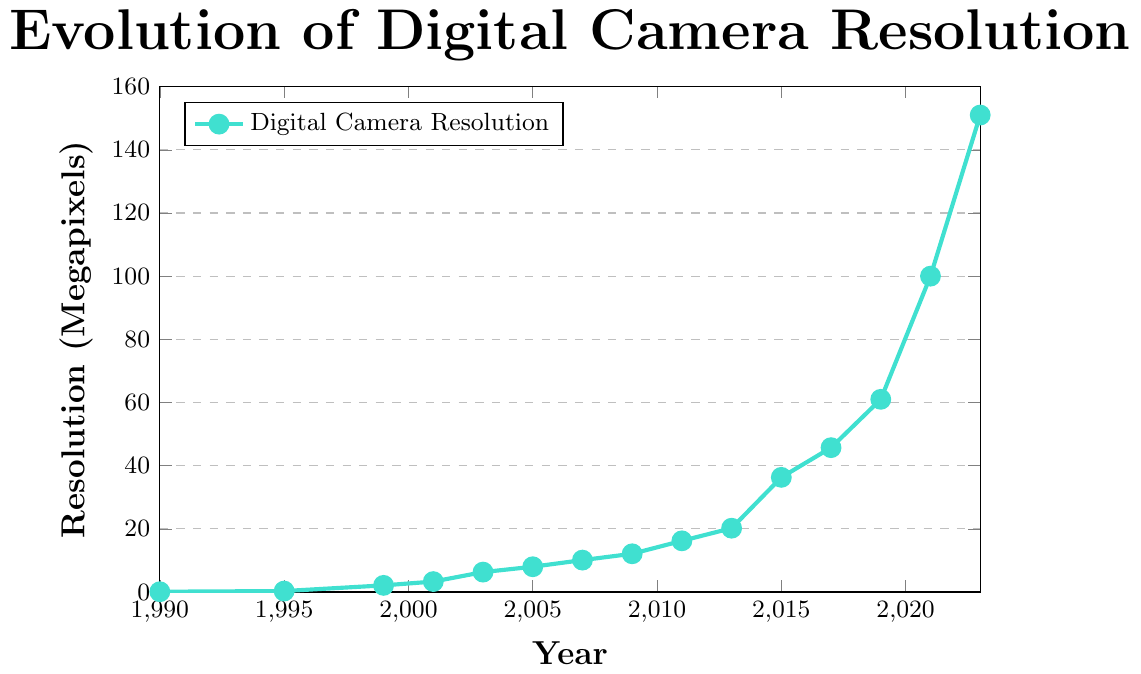What is the resolution trend from 1990 to 2023? The resolution of digital cameras shows a significant upward trend from 1990 to 2023. Starting at 0.09 megapixels in 1990, there is a steady increase with a notable acceleration in resolution improvements after 2011. By 2023, the resolution reaches 151 megapixels.
Answer: Upward Trend Which year shows the most significant jump in resolution? By comparing the differences between consecutive years, the year 2021 shows the most significant increase in resolution. The jump from 61 megapixels in 2019 to 100 megapixels in 2021 is the largest increment.
Answer: 2021 How many years did it take for the resolution to increase from 2.1 megapixels to 16.2 megapixels? The resolution was 2.1 megapixels in 1999 and reached 16.2 megapixels in 2011. The difference between those years is 2011 - 1999 = 12 years.
Answer: 12 years What is the average resolution increase per year from 2011 to 2023? The resolution in 2011 was 16.2 megapixels and in 2023 it was 151 megapixels. The increase is 151 - 16.2 = 134.8 megapixels. The number of years is 2023 - 2011 = 12. So, the average increase per year is 134.8 / 12 = 11.23 megapixels/year.
Answer: 11.23 megapixels/year How does the resolution in 2015 compare to the resolution in 2017? The resolution in 2015 was 36.3 megapixels, and in 2017 it was 45.7 megapixels. 45.7 is greater than 36.3, thus the resolution increased from 2015 to 2017 by 45.7 - 36.3 = 9.4 megapixels.
Answer: 9.4 megapixels What was the resolution in the year 2001? By looking at the data points on the figure, the resolution in the year 2001 was 3.3 megapixels.
Answer: 3.3 megapixels What is the total increase in resolution from 1990 to 2023? The resolution in 1990 was 0.09 megapixels, and in 2023 it was 151 megapixels. The total increase is 151 - 0.09 = 150.91 megapixels.
Answer: 150.91 megapixels In which period was the resolution growth the slowest, i.e., the smallest increase in megapixels over a span of time? The slowest growth was between 1990 and 1995, where the resolution increased from 0.09 to 0.3 megapixels, a difference of only 0.21 megapixels over 5 years.
Answer: 1990-1995 What is the resolution increase percentage from 2005 to 2009? The resolution in 2005 was 8.0 megapixels and in 2009 it was 12.1 megapixels. The percentage increase is ((12.1 - 8.0) / 8.0) * 100 = 51.25%.
Answer: 51.25% What is the color of the line used to represent the data points in the plot? The line representing the data points in the figure is colored turquoise.
Answer: Turquoise 